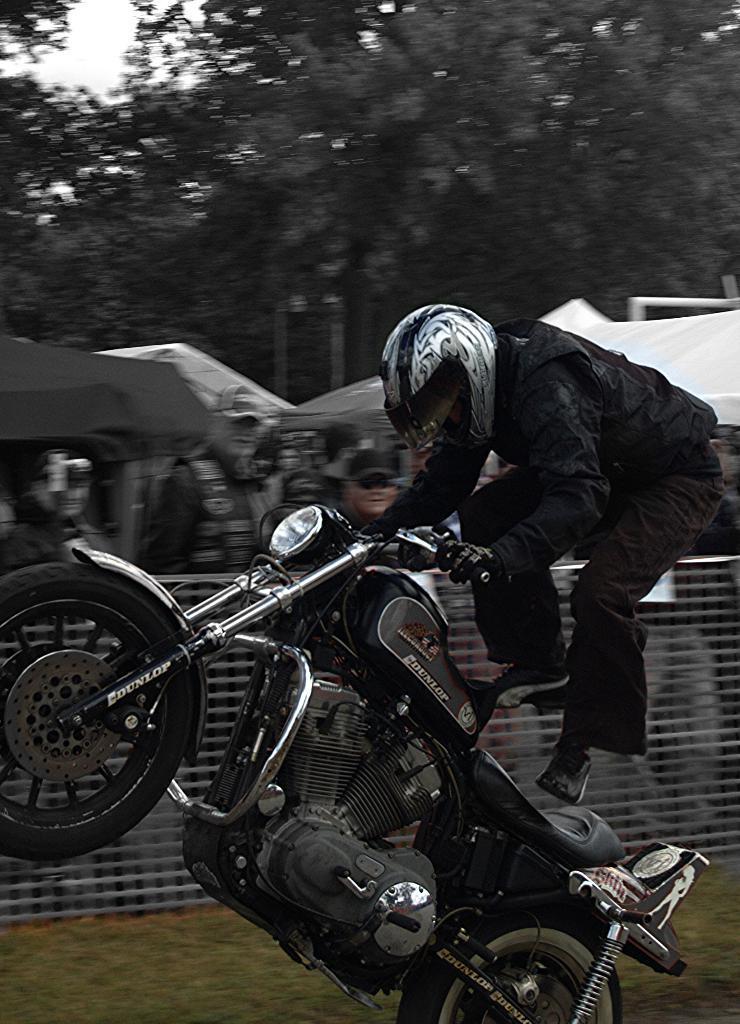Could you give a brief overview of what you see in this image? In this picture we can find man on the bike doing stunt. In the background we can find a railing, some tents, trees, and sky. A man on the bike is wearing a helmet, and a black jacket. 